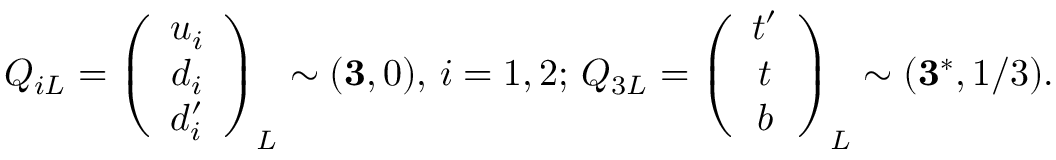<formula> <loc_0><loc_0><loc_500><loc_500>Q _ { i L } = \left ( \begin{array} { c } { { u _ { i } } } \\ { { d _ { i } } } \\ { { d _ { i } ^ { \prime } } } \end{array} \right ) _ { L } \sim ( { 3 } , 0 ) , \, i = 1 , 2 ; \, Q _ { 3 L } = \left ( \begin{array} { c } { { t ^ { \prime } } } \\ { t } \\ { b } \end{array} \right ) _ { L } \sim ( { 3 } ^ { * } , 1 / 3 ) .</formula> 